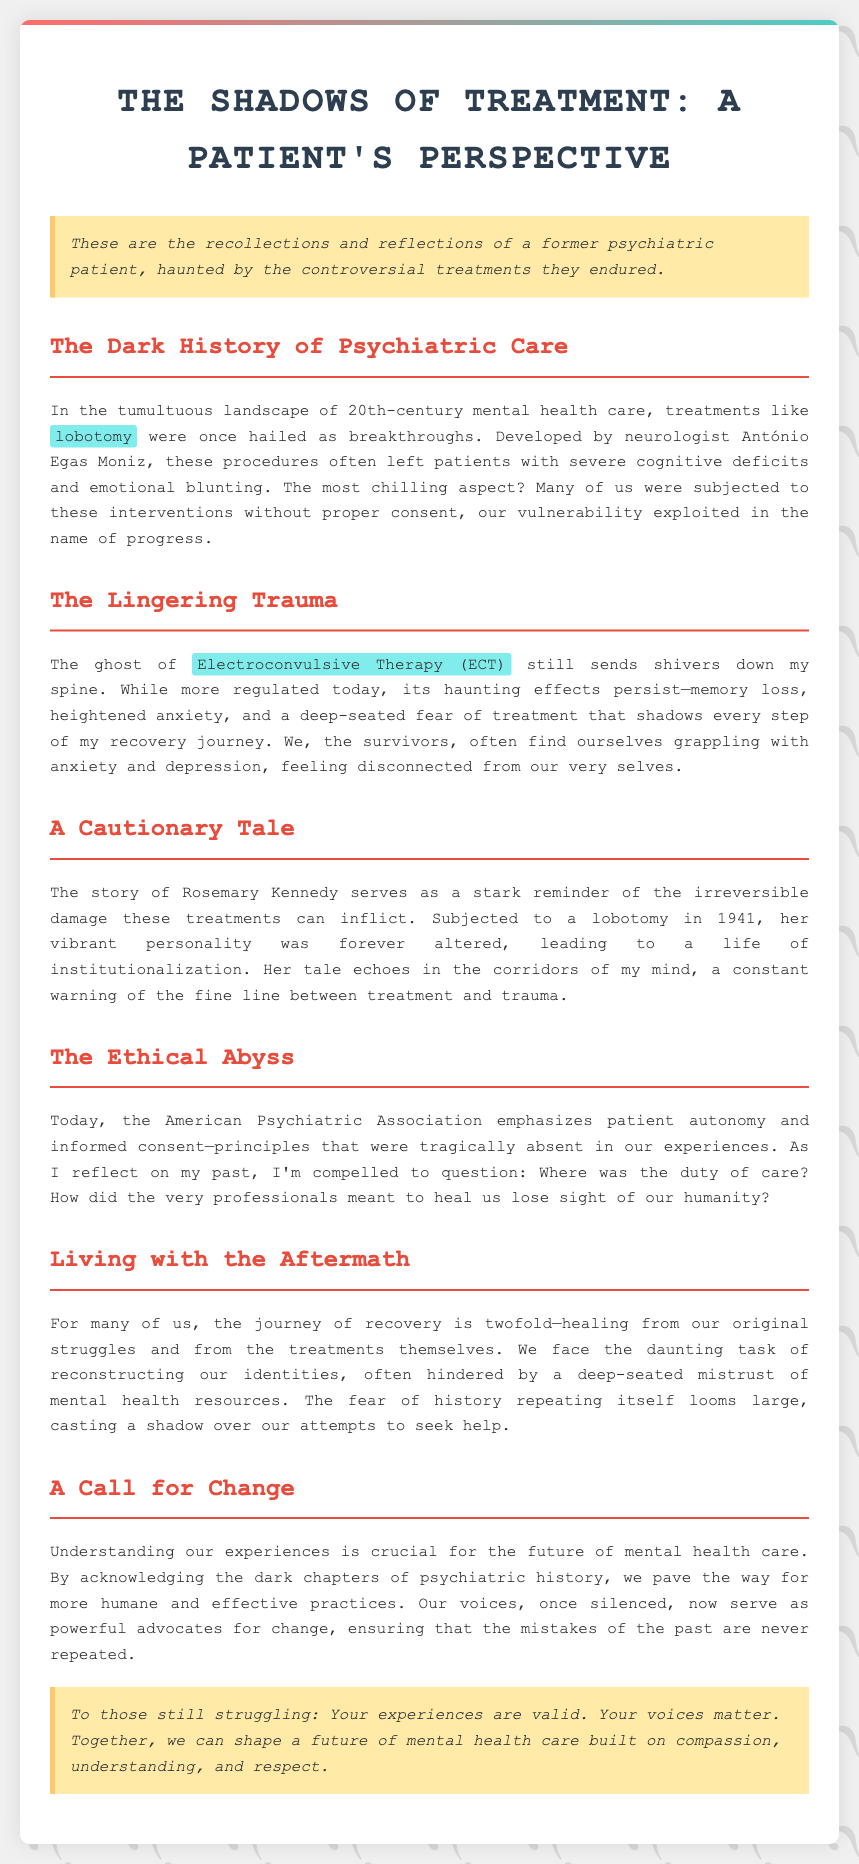what treatment was developed by António Egas Moniz? The document mentions lobotomy as the treatment developed by neurologist António Egas Moniz.
Answer: lobotomy what is a chilling effect of Electroconvulsive Therapy? The document states that a chilling effect of ECT is memory loss.
Answer: memory loss who was subjected to a lobotomy in 1941? The document notes that Rosemary Kennedy was subjected to a lobotomy in 1941.
Answer: Rosemary Kennedy what major principle emphasizes patient autonomy today? The document refers to informed consent as a major principle that emphasizes patient autonomy today.
Answer: informed consent what is the daunting task faced by many former patients? The document explains that many former patients face the daunting task of reconstructing their identities.
Answer: reconstructing their identities what is crucial for the future of mental health care? The document states that understanding our experiences is crucial for the future of mental health care.
Answer: understanding our experiences what phrase describes current principles in psychiatric care? The document describes patient autonomy and informed consent as current principles in psychiatric care.
Answer: patient autonomy and informed consent what does the author question about the professionals meant to heal? The author questions where the duty of care was among the professionals meant to heal.
Answer: duty of care what characterizes the author's recollections? The document characterizes the author's recollections as haunted by controversial treatments endured.
Answer: haunted by controversial treatments 